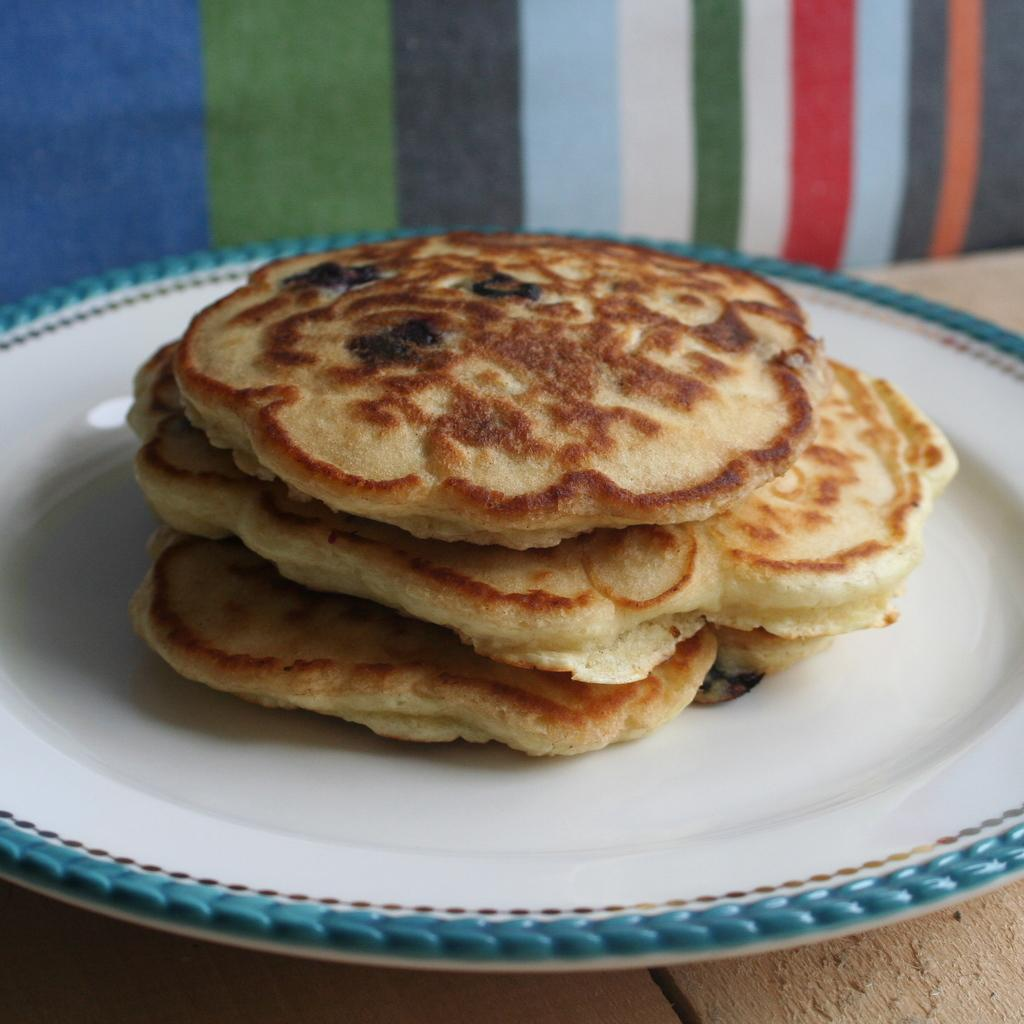What is the color of the plate in the image? The plate in the image is white. What is on the plate? There is food on the plate. Can you describe the colorful object in the image? Unfortunately, the provided facts do not mention a colorful object in the image. What type of trouble is the beggar causing in the image? There is no beggar present in the image, so it is not possible to answer that question. 